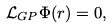<formula> <loc_0><loc_0><loc_500><loc_500>\mathcal { L } _ { G P } \Phi ( r ) = 0 ,</formula> 